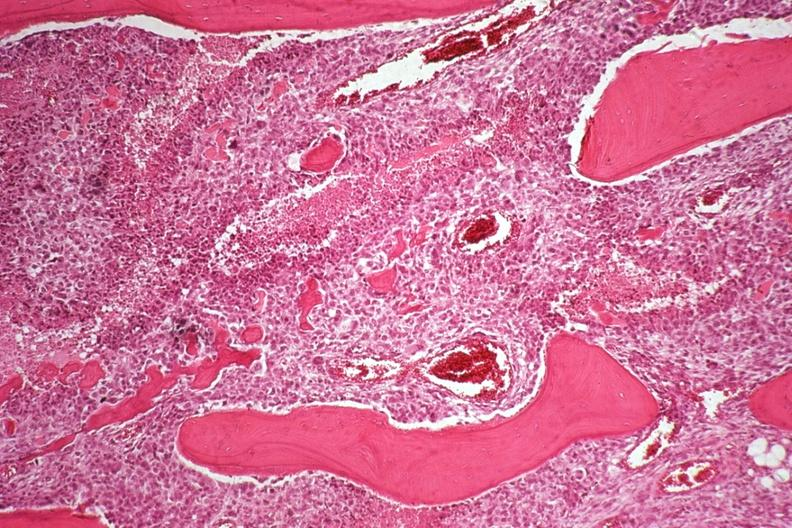does this image show neoplastic osteoblasts and tumor osteoid?
Answer the question using a single word or phrase. Yes 